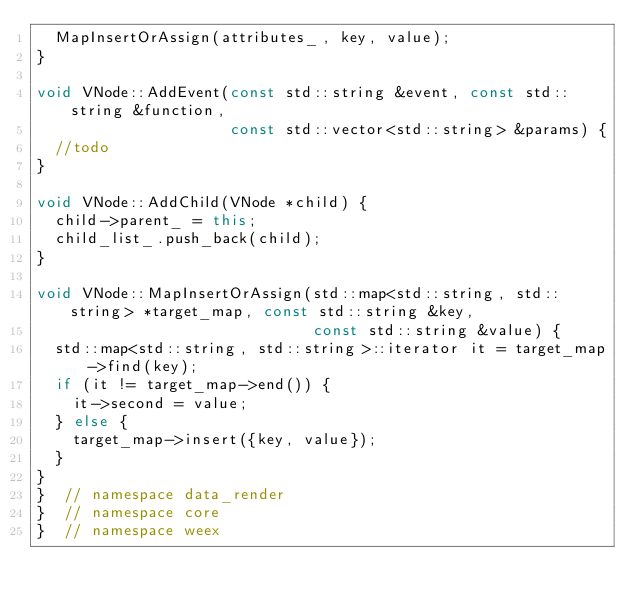Convert code to text. <code><loc_0><loc_0><loc_500><loc_500><_C++_>  MapInsertOrAssign(attributes_, key, value);
}

void VNode::AddEvent(const std::string &event, const std::string &function,
                     const std::vector<std::string> &params) {
  //todo
}

void VNode::AddChild(VNode *child) {
  child->parent_ = this;
  child_list_.push_back(child);
}

void VNode::MapInsertOrAssign(std::map<std::string, std::string> *target_map, const std::string &key,
                              const std::string &value) {
  std::map<std::string, std::string>::iterator it = target_map->find(key);
  if (it != target_map->end()) {
    it->second = value;
  } else {
    target_map->insert({key, value});
  }
}
}  // namespace data_render
}  // namespace core
}  // namespace weex</code> 